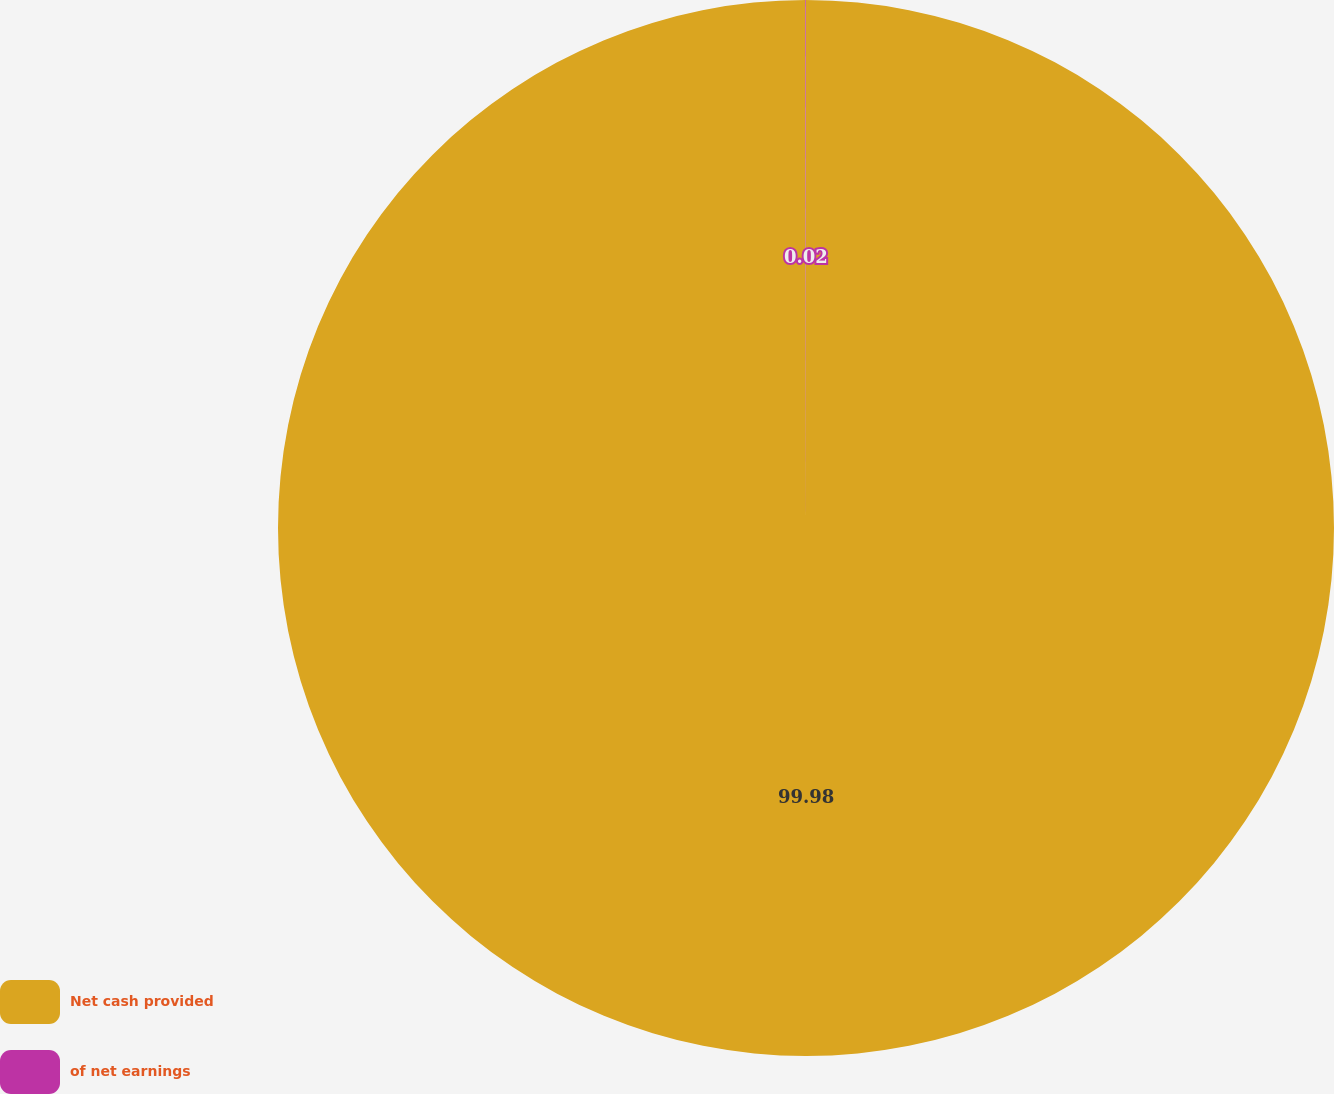<chart> <loc_0><loc_0><loc_500><loc_500><pie_chart><fcel>Net cash provided<fcel>of net earnings<nl><fcel>99.98%<fcel>0.02%<nl></chart> 